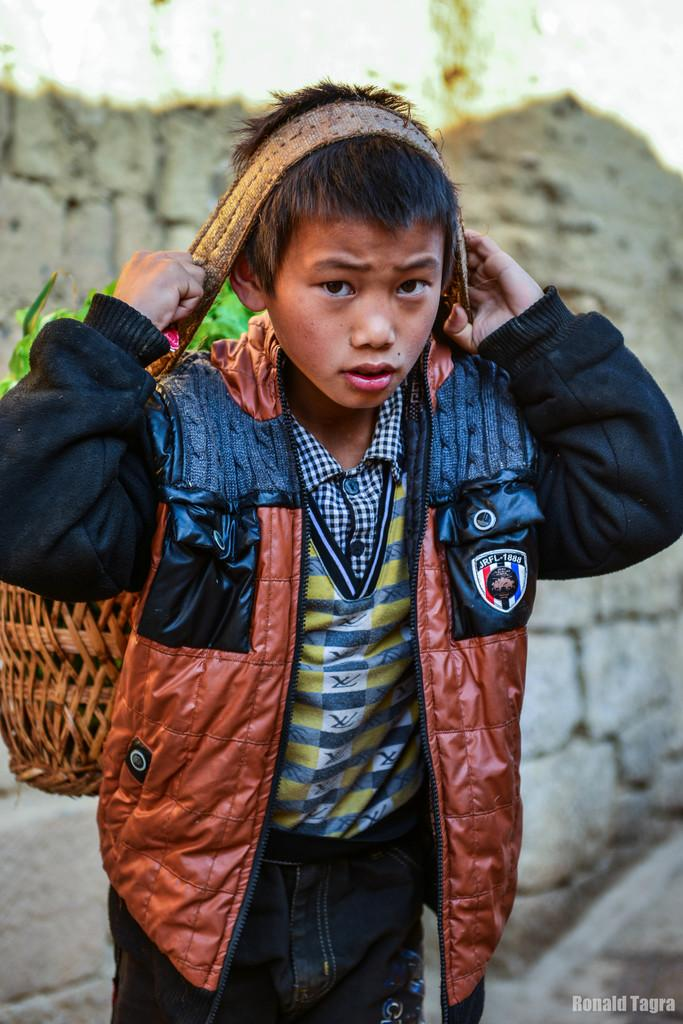What is the main subject in the foreground of the image? There is a boy in the foreground of the image. What is the boy wearing? The boy is wearing a jacket. What is the boy carrying in the image? The boy is carrying a basket. How is the basket secured to the boy's head? The basket is secured to the boy's head with a belt. What can be seen in the background of the image? There is a wall in the background of the image. What type of basin is visible in the image? There is no basin present in the image. Can you tell me how many cables are connected to the boy's jacket? There are no cables connected to the boy's jacket in the image. 